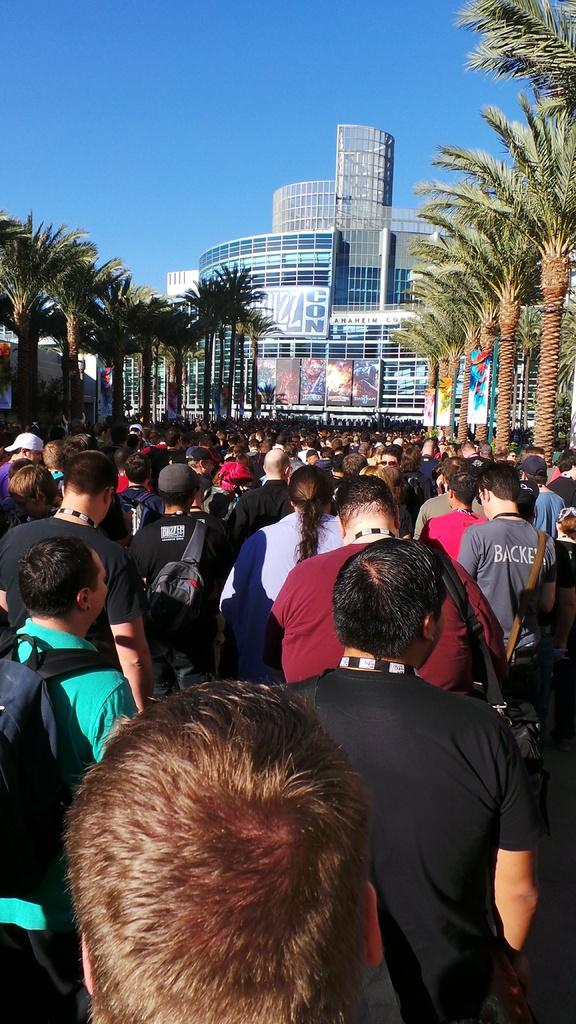What is happening in the image? There is a crowd of people in the image, and they are walking in the street. What can be seen in the background of the image? There is a building in the image. What is a feature of the building? The building has window glasses. What type of writing can be seen on the building in the image? There is no writing visible on the building in the image; only window glasses are mentioned. What kind of argument is taking place between the people in the crowd? There is no indication of an argument in the image; the people are simply walking in the street. 